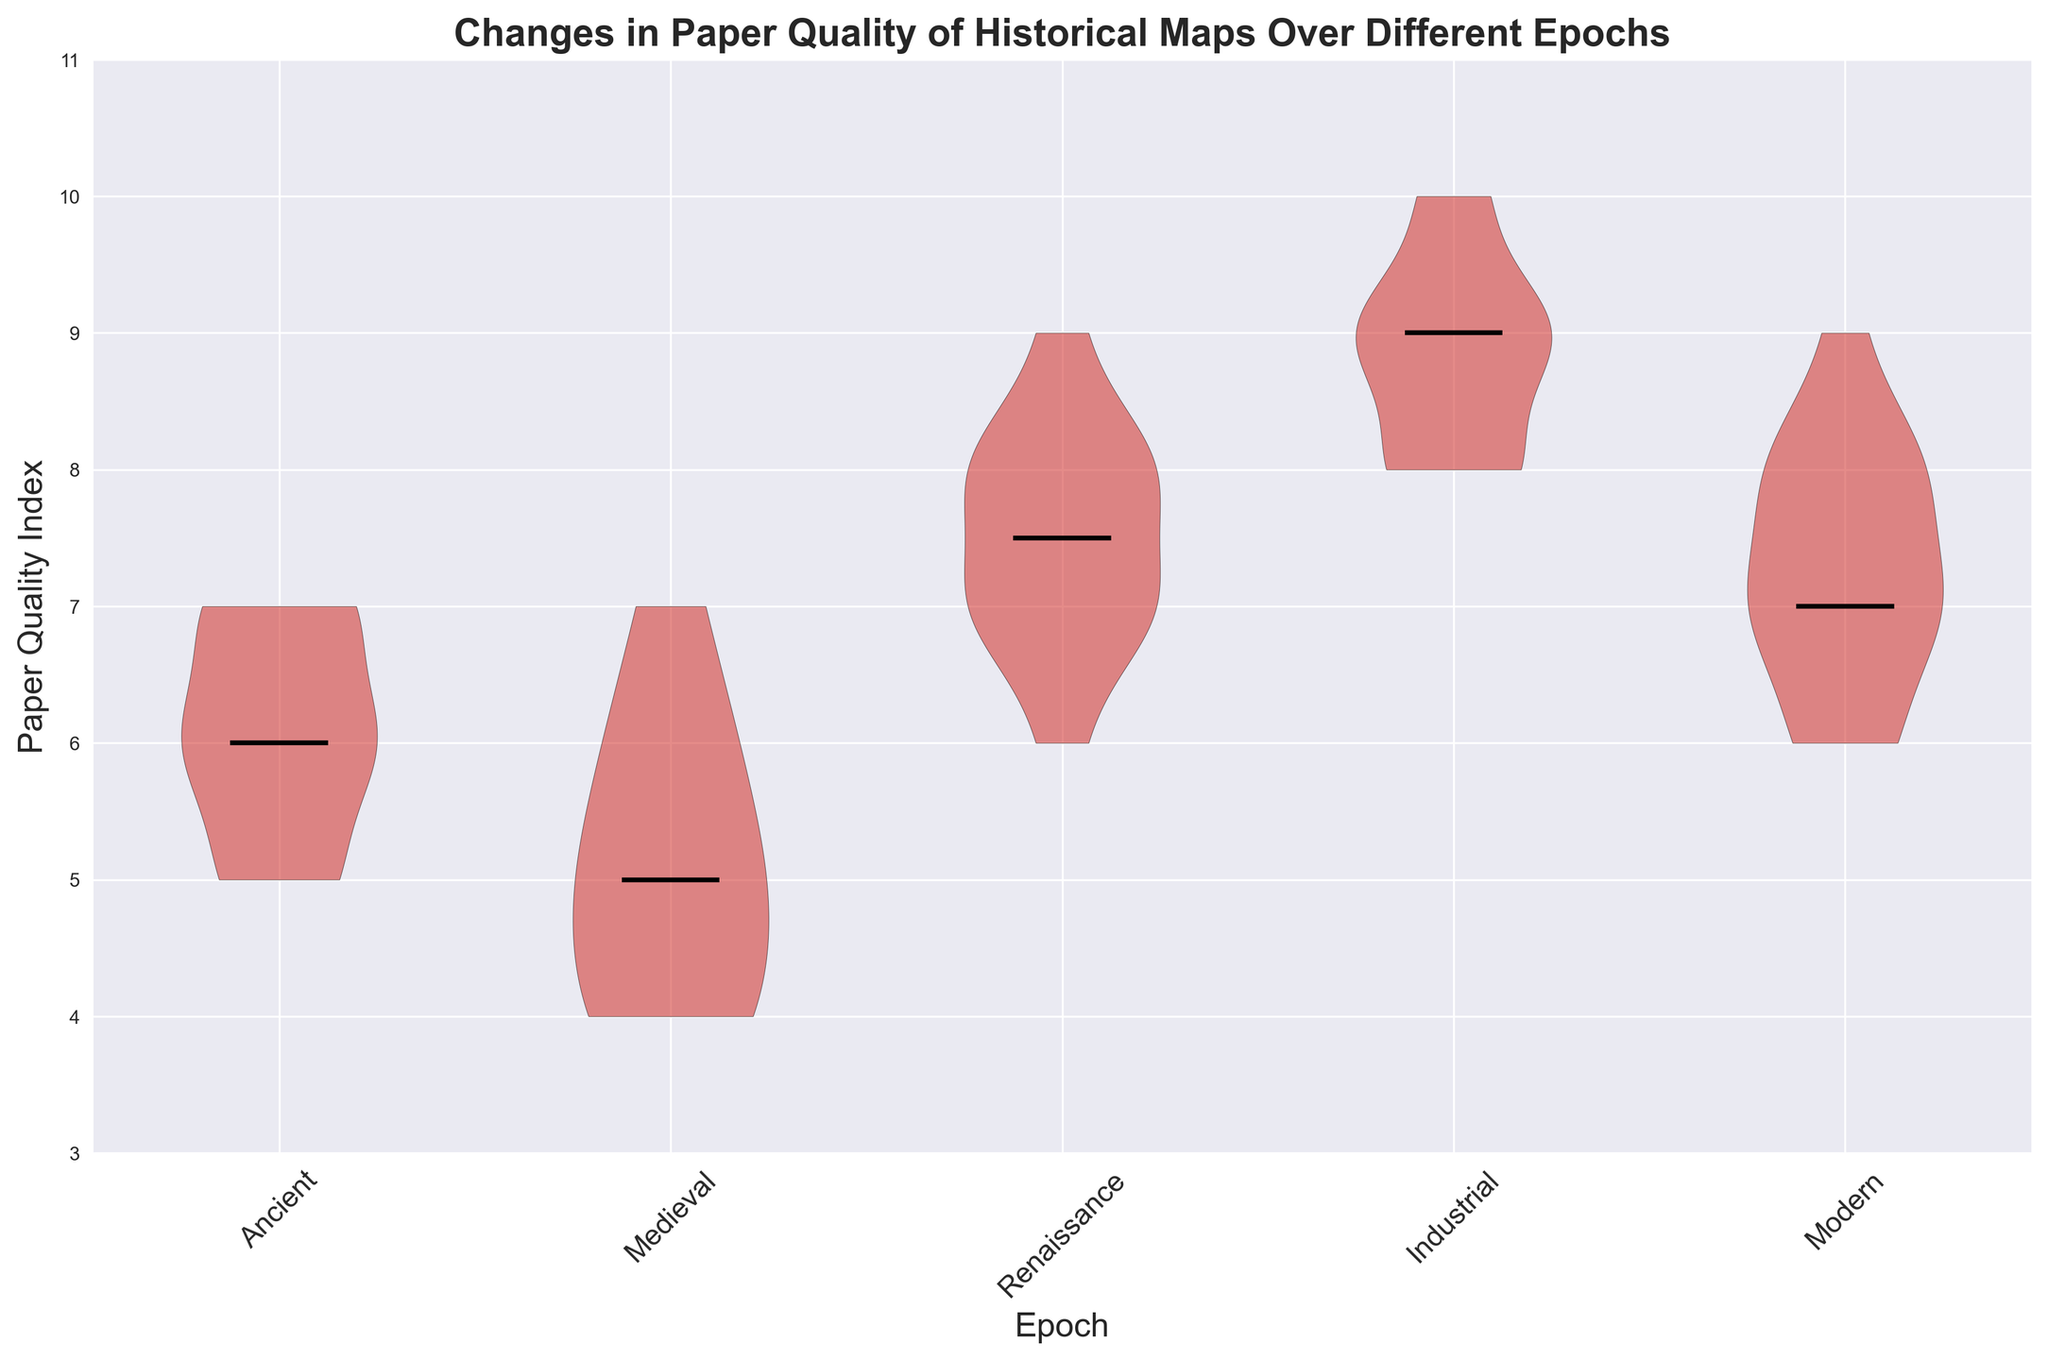Which epoch has the highest median paper quality index? To determine the epoch with the highest median, look for the thick black line (representing the median) at the highest value on the y-axis. The Renaissance and Industrial epochs have the highest medians, both around 8.
Answer: Renaissance and Industrial Which epoch shows the greatest variability in paper quality index? Variability can be judged by the width of the 'violin' shape. The Industrial epoch has the broadest violin, indicating the greatest spread of values.
Answer: Industrial How does the median paper quality index of the Renaissance epoch compare to the Medieval epoch? Identify the median lines for both epochs: the Renaissance median is around 8, while the Medieval median is around 5. Hence, the Renaissance median is greater.
Answer: Renaissance > Medieval Which epoch has the most consistently high paper quality index? Consistency can be observed through the narrowest and highest 'violin'. The Industrial epoch has a high median and consistent values clustered around it.
Answer: Industrial Is there an epoch where the majority of values are below 6? Look for an epoch where most of the violin plot is below the value of 6 on the y-axis. The Medieval epoch shows this pattern.
Answer: Medieval Compare the range of paper quality index in the Ancient epoch and the Modern epoch. The range can be identified by the spread of the violin plot on the y-axis. The Ancient epoch ranges approximately from 5 to 7, while the Modern epoch ranges from about 6 to 9.
Answer: Ancient: 5-7, Modern: 6-9 What is the paper quality index value for the median of the Modern epoch? Find the thick black line in the Modern epoch's violin plot. It is around the value of 7.
Answer: 7 Which epoch demonstrates an overall increase in paper quality when compared to the previous epoch? Look at the median lines across epochs and compare sequentially: from Medieval (around 5) to Renaissance (around 8), indicating an increase.
Answer: Renaissance In which epoch does the paper quality deviate the least from its median? The smallest deviation can be seen where the violin plot is narrowest around the median. The Renaissance epoch seems to show this characteristic.
Answer: Renaissance Rank the epochs in ascending order based on their median paper quality index. Observe each median from the lowest to highest: Medieval (5), Ancient (6), Modern (7), Renaissance and Industrial (both 8).
Answer: Medieval < Ancient < Modern < Renaissance = Industrial 